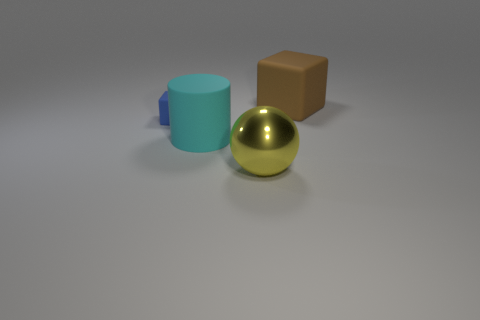Add 1 small purple matte balls. How many objects exist? 5 Subtract 1 cylinders. How many cylinders are left? 0 Subtract all spheres. How many objects are left? 3 Add 4 large brown objects. How many large brown objects exist? 5 Subtract all brown cubes. How many cubes are left? 1 Subtract 0 green blocks. How many objects are left? 4 Subtract all green cubes. Subtract all red cylinders. How many cubes are left? 2 Subtract all large gray blocks. Subtract all brown things. How many objects are left? 3 Add 1 tiny blue things. How many tiny blue things are left? 2 